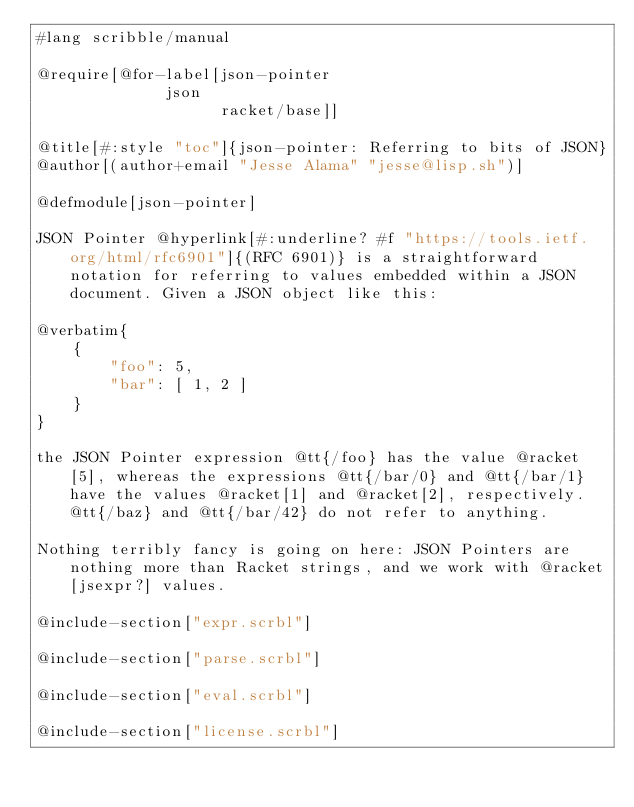<code> <loc_0><loc_0><loc_500><loc_500><_Racket_>#lang scribble/manual

@require[@for-label[json-pointer
	            json
                    racket/base]]

@title[#:style "toc"]{json-pointer: Referring to bits of JSON}
@author[(author+email "Jesse Alama" "jesse@lisp.sh")]

@defmodule[json-pointer]

JSON Pointer @hyperlink[#:underline? #f "https://tools.ietf.org/html/rfc6901"]{(RFC 6901)} is a straightforward notation for referring to values embedded within a JSON document. Given a JSON object like this:

@verbatim{
    {
        "foo": 5,
        "bar": [ 1, 2 ]
    }
}

the JSON Pointer expression @tt{/foo} has the value @racket[5], whereas the expressions @tt{/bar/0} and @tt{/bar/1} have the values @racket[1] and @racket[2], respectively. @tt{/baz} and @tt{/bar/42} do not refer to anything.

Nothing terribly fancy is going on here: JSON Pointers are nothing more than Racket strings, and we work with @racket[jsexpr?] values.

@include-section["expr.scrbl"]

@include-section["parse.scrbl"]

@include-section["eval.scrbl"]

@include-section["license.scrbl"]
</code> 